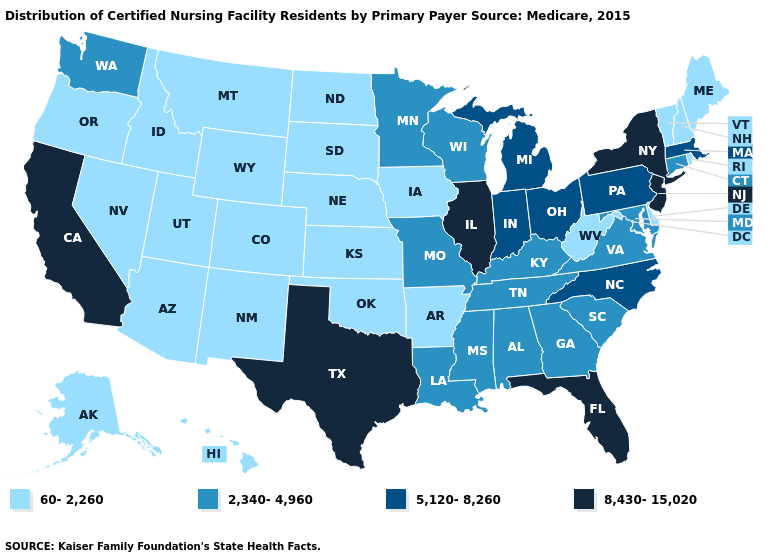Does the first symbol in the legend represent the smallest category?
Be succinct. Yes. What is the highest value in states that border Iowa?
Be succinct. 8,430-15,020. Among the states that border Pennsylvania , does Ohio have the highest value?
Answer briefly. No. What is the lowest value in the South?
Give a very brief answer. 60-2,260. What is the lowest value in states that border Massachusetts?
Write a very short answer. 60-2,260. Does Texas have the highest value in the South?
Short answer required. Yes. What is the lowest value in the USA?
Give a very brief answer. 60-2,260. What is the value of Washington?
Write a very short answer. 2,340-4,960. Does Virginia have a higher value than Ohio?
Write a very short answer. No. What is the value of Arkansas?
Answer briefly. 60-2,260. Name the states that have a value in the range 60-2,260?
Answer briefly. Alaska, Arizona, Arkansas, Colorado, Delaware, Hawaii, Idaho, Iowa, Kansas, Maine, Montana, Nebraska, Nevada, New Hampshire, New Mexico, North Dakota, Oklahoma, Oregon, Rhode Island, South Dakota, Utah, Vermont, West Virginia, Wyoming. What is the value of Massachusetts?
Answer briefly. 5,120-8,260. Name the states that have a value in the range 60-2,260?
Be succinct. Alaska, Arizona, Arkansas, Colorado, Delaware, Hawaii, Idaho, Iowa, Kansas, Maine, Montana, Nebraska, Nevada, New Hampshire, New Mexico, North Dakota, Oklahoma, Oregon, Rhode Island, South Dakota, Utah, Vermont, West Virginia, Wyoming. Which states have the lowest value in the MidWest?
Short answer required. Iowa, Kansas, Nebraska, North Dakota, South Dakota. Name the states that have a value in the range 2,340-4,960?
Answer briefly. Alabama, Connecticut, Georgia, Kentucky, Louisiana, Maryland, Minnesota, Mississippi, Missouri, South Carolina, Tennessee, Virginia, Washington, Wisconsin. 